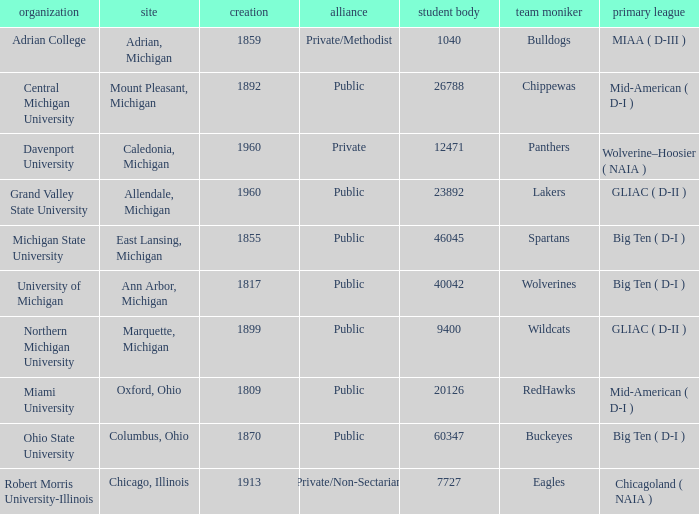What is the location of robert morris university-illinois? Chicago, Illinois. 